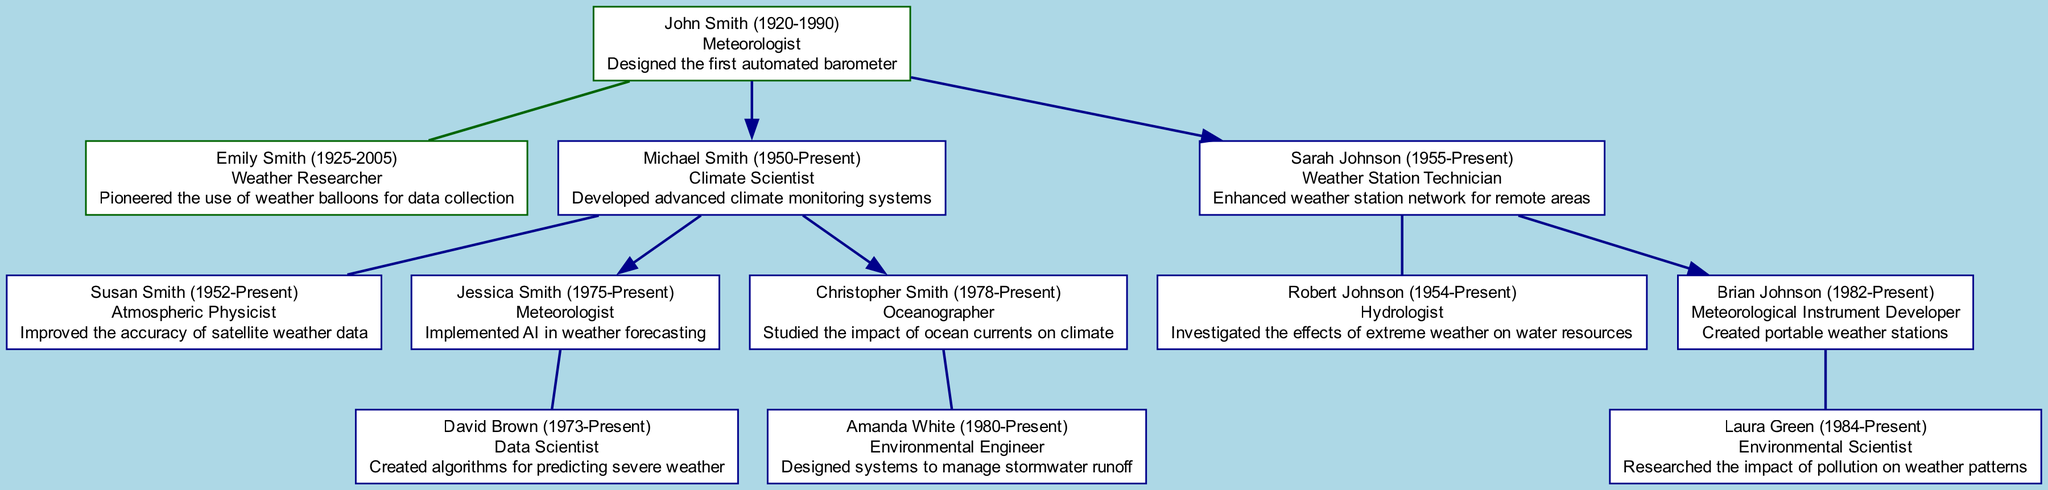What is the profession of John Smith? The diagram indicates that John Smith is a "Meteorologist." This information is located in the details associated with his node.
Answer: Meteorologist How many children did Michael Smith and Susan Smith have? In the diagram, Michael Smith and Susan Smith are shown to have two children: Jessica Smith and Christopher Smith. This can be verified by counting the child nodes connected to their node.
Answer: 2 What contribution did Sarah Johnson make? According to the node details for Sarah Johnson, her contribution is that she "Enhanced weather station network for remote areas." This information is presented directly under her profession.
Answer: Enhanced weather station network for remote areas Who is the spouse of Brian Johnson? The diagram shows that Brian Johnson is married to Laura Green. This connection is represented by a direct edge leading from Brian's node to Laura's node.
Answer: Laura Green What year was Jessica Smith born? By examining the node for Jessica Smith, it states her birth year is 1975. This is a specific detail included in her node label.
Answer: 1975 Which child of John Smith has a profession as a Climate Scientist? The diagram indicates that Michael Smith is the child of John Smith and is identified as a "Climate Scientist." This information is found in the detailed node for Michael Smith.
Answer: Michael Smith How many generations are represented in the family tree? If we analyze the tree structure, there are three generations: the roots (John and Emily Smith), their children (Michael Smith, Sarah Johnson), and their grandchildren (Jessica, Christopher, and Brian). This can be counted by looking at the hierarchy of nodes.
Answer: 3 What was the contribution of Amanda White? The node for Amanda White shows that her contribution is "Designed systems to manage stormwater runoff." This information is clearly stated under her details in the diagram.
Answer: Designed systems to manage stormwater runoff Which profession does David Brown have? In the diagram, David Brown is identified as a "Data Scientist," which is detailed in his individual node.
Answer: Data Scientist 